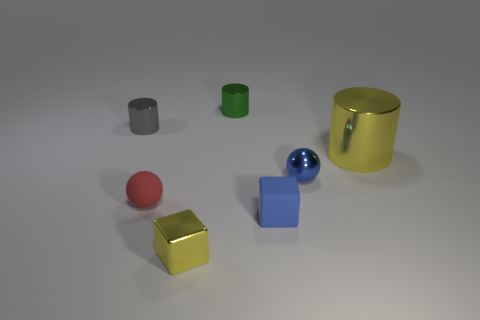There is a tiny gray thing that is the same shape as the big object; what material is it?
Offer a very short reply. Metal. The metallic sphere that is the same size as the green thing is what color?
Provide a short and direct response. Blue. Are there an equal number of green things in front of the small red matte ball and small red balls?
Offer a terse response. No. There is a matte thing right of the yellow object on the left side of the large cylinder; what is its color?
Offer a terse response. Blue. What size is the shiny thing that is to the right of the ball right of the rubber ball?
Offer a very short reply. Large. What size is the cylinder that is the same color as the metal block?
Provide a succinct answer. Large. How many other objects are the same size as the red thing?
Offer a very short reply. 5. There is a ball that is to the right of the cylinder behind the thing that is to the left of the red object; what is its color?
Provide a short and direct response. Blue. What number of other objects are the same shape as the red object?
Your answer should be compact. 1. What shape is the object that is behind the gray shiny thing?
Offer a terse response. Cylinder. 